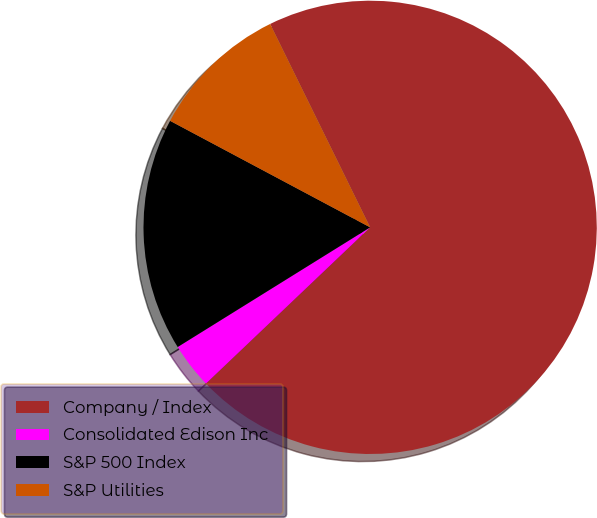Convert chart to OTSL. <chart><loc_0><loc_0><loc_500><loc_500><pie_chart><fcel>Company / Index<fcel>Consolidated Edison Inc<fcel>S&P 500 Index<fcel>S&P Utilities<nl><fcel>70.17%<fcel>3.25%<fcel>16.64%<fcel>9.94%<nl></chart> 